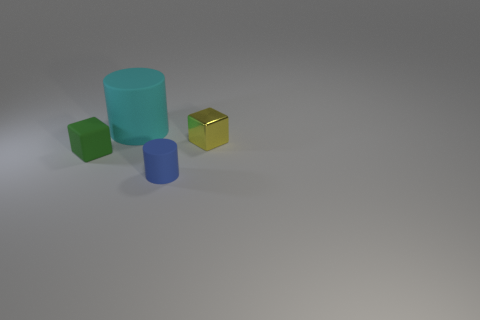Add 1 tiny yellow objects. How many objects exist? 5 Subtract all big gray matte blocks. Subtract all yellow metal things. How many objects are left? 3 Add 1 tiny yellow things. How many tiny yellow things are left? 2 Add 3 tiny brown objects. How many tiny brown objects exist? 3 Subtract 1 green blocks. How many objects are left? 3 